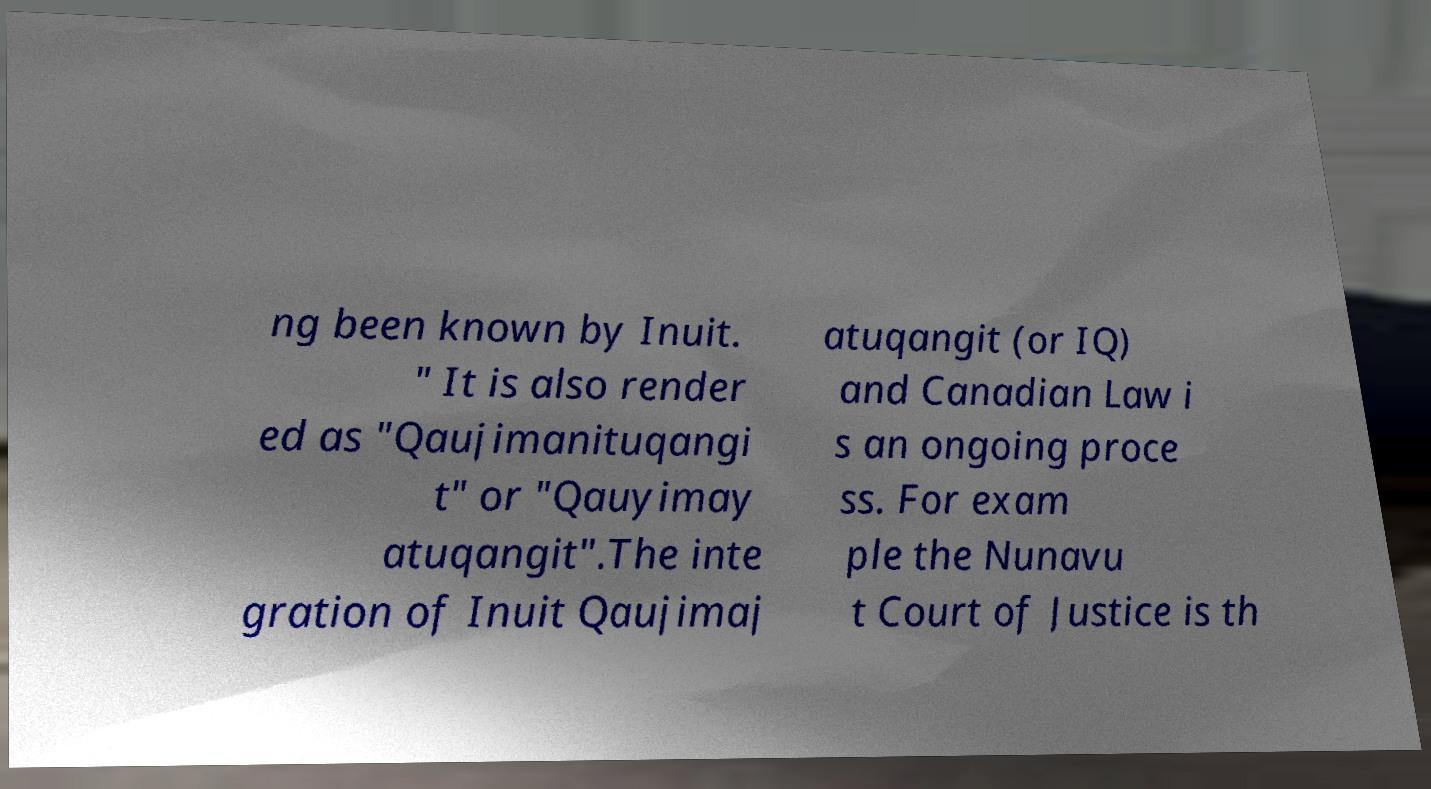Can you accurately transcribe the text from the provided image for me? ng been known by Inuit. " It is also render ed as "Qaujimanituqangi t" or "Qauyimay atuqangit".The inte gration of Inuit Qaujimaj atuqangit (or IQ) and Canadian Law i s an ongoing proce ss. For exam ple the Nunavu t Court of Justice is th 